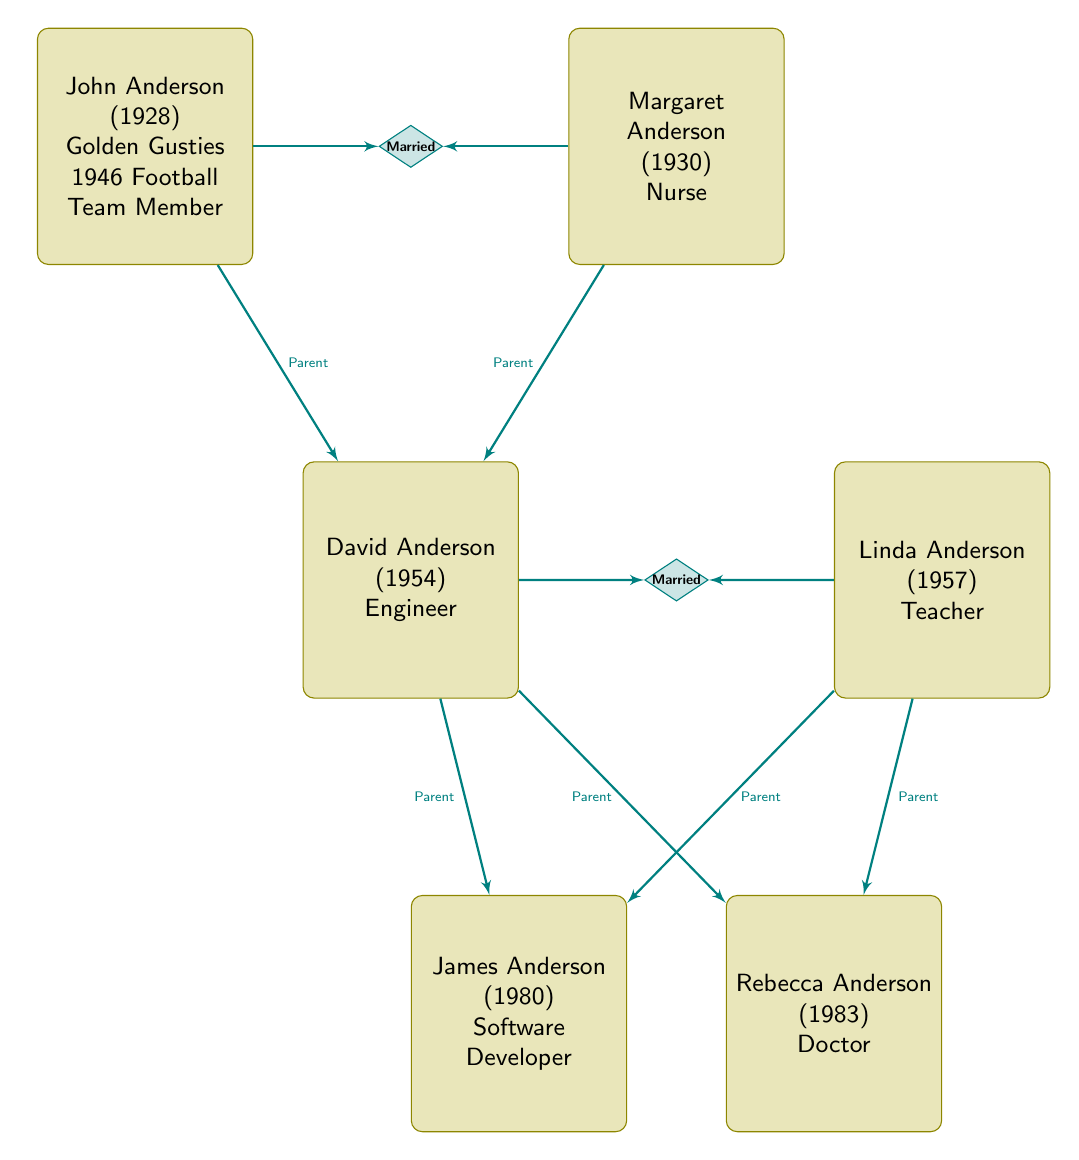What is the occupation of Margaret Anderson? The diagram shows that Margaret Anderson's attributes include her occupation, which is explicitly stated as "Nurse."
Answer: Nurse Who are the parents of James Anderson? From the diagram, it indicates that both David Anderson and Linda Anderson have a "Parent" relationship toward James and are connected by the lines labeled as "Parent."
Answer: David Anderson, Linda Anderson How many grandchildren does John Anderson have? The diagram reveals that John Anderson has two grandchildren: James Anderson and Rebecca Anderson. Thus, counting these, we see that there are two grandchildren.
Answer: 2 What is the birth year of Rebecca Anderson? In the diagram, Rebecca Anderson's attributes include a birth year, which is noted as 1983.
Answer: 1983 Which relationship connects John Anderson and Margaret Anderson? The relationship identified between John Anderson and Margaret Anderson is labeled as "Married" in the diagram, clearly indicating their connection.
Answer: Married Who is the son of John Anderson? The diagram denotes that David Anderson has a "Parent" relationship with John Anderson, classifying him as his son.
Answer: David Anderson What are the occupations of David and Linda Anderson combined? According to the diagram, David Anderson is an "Engineer" and Linda Anderson is a "Teacher." Therefore, combining these two occupations yields both titles.
Answer: Engineer, Teacher How is James Anderson related to Margaret Anderson? The diagram depicts James Anderson as the child of David and Linda, making him the grandson of Margaret Anderson. Thus, the relationship can be defined as "Grandson."
Answer: Grandson 